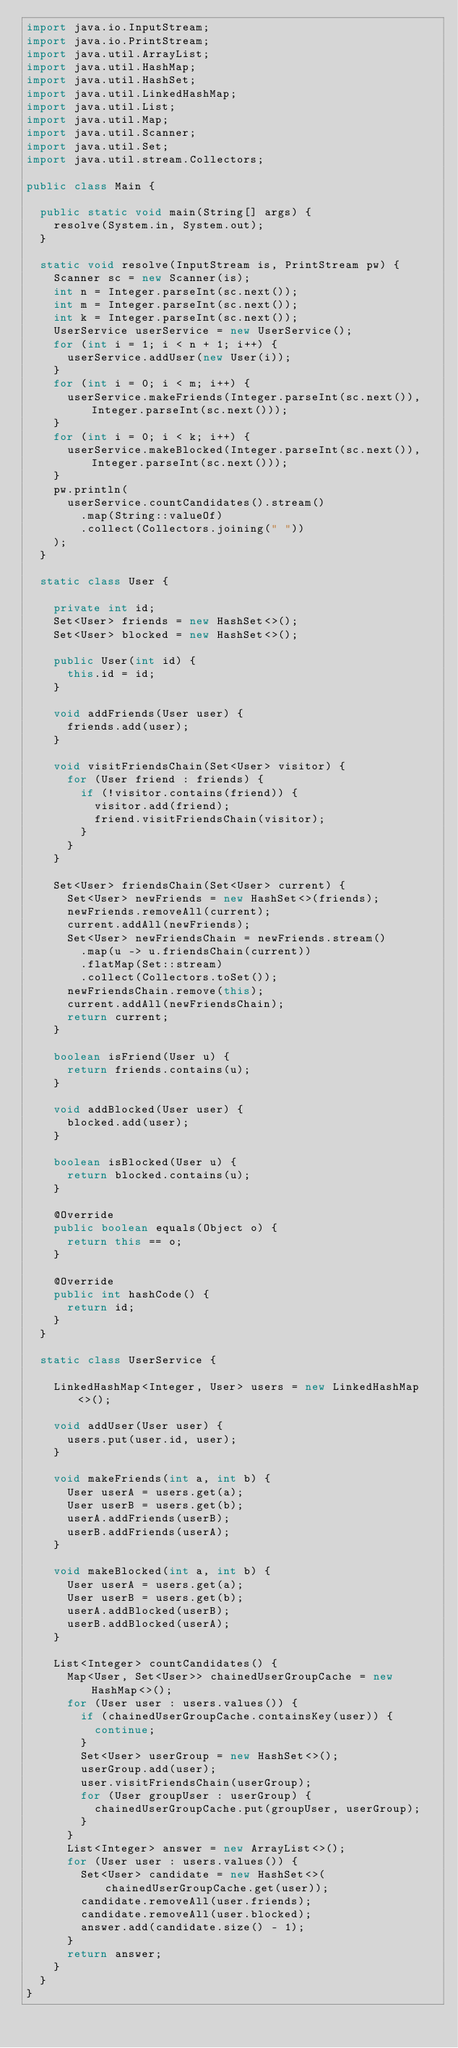<code> <loc_0><loc_0><loc_500><loc_500><_Java_>import java.io.InputStream;
import java.io.PrintStream;
import java.util.ArrayList;
import java.util.HashMap;
import java.util.HashSet;
import java.util.LinkedHashMap;
import java.util.List;
import java.util.Map;
import java.util.Scanner;
import java.util.Set;
import java.util.stream.Collectors;

public class Main {

  public static void main(String[] args) {
    resolve(System.in, System.out);
  }

  static void resolve(InputStream is, PrintStream pw) {
    Scanner sc = new Scanner(is);
    int n = Integer.parseInt(sc.next());
    int m = Integer.parseInt(sc.next());
    int k = Integer.parseInt(sc.next());
    UserService userService = new UserService();
    for (int i = 1; i < n + 1; i++) {
      userService.addUser(new User(i));
    }
    for (int i = 0; i < m; i++) {
      userService.makeFriends(Integer.parseInt(sc.next()), Integer.parseInt(sc.next()));
    }
    for (int i = 0; i < k; i++) {
      userService.makeBlocked(Integer.parseInt(sc.next()), Integer.parseInt(sc.next()));
    }
    pw.println(
      userService.countCandidates().stream()
        .map(String::valueOf)
        .collect(Collectors.joining(" "))
    );
  }

  static class User {

    private int id;
    Set<User> friends = new HashSet<>();
    Set<User> blocked = new HashSet<>();

    public User(int id) {
      this.id = id;
    }

    void addFriends(User user) {
      friends.add(user);
    }

    void visitFriendsChain(Set<User> visitor) {
      for (User friend : friends) {
        if (!visitor.contains(friend)) {
          visitor.add(friend);
          friend.visitFriendsChain(visitor);
        }
      }
    }

    Set<User> friendsChain(Set<User> current) {
      Set<User> newFriends = new HashSet<>(friends);
      newFriends.removeAll(current);
      current.addAll(newFriends);
      Set<User> newFriendsChain = newFriends.stream()
        .map(u -> u.friendsChain(current))
        .flatMap(Set::stream)
        .collect(Collectors.toSet());
      newFriendsChain.remove(this);
      current.addAll(newFriendsChain);
      return current;
    }

    boolean isFriend(User u) {
      return friends.contains(u);
    }

    void addBlocked(User user) {
      blocked.add(user);
    }

    boolean isBlocked(User u) {
      return blocked.contains(u);
    }

    @Override
    public boolean equals(Object o) {
      return this == o;
    }

    @Override
    public int hashCode() {
      return id;
    }
  }

  static class UserService {

    LinkedHashMap<Integer, User> users = new LinkedHashMap<>();

    void addUser(User user) {
      users.put(user.id, user);
    }

    void makeFriends(int a, int b) {
      User userA = users.get(a);
      User userB = users.get(b);
      userA.addFriends(userB);
      userB.addFriends(userA);
    }

    void makeBlocked(int a, int b) {
      User userA = users.get(a);
      User userB = users.get(b);
      userA.addBlocked(userB);
      userB.addBlocked(userA);
    }

    List<Integer> countCandidates() {
      Map<User, Set<User>> chainedUserGroupCache = new HashMap<>();
      for (User user : users.values()) {
        if (chainedUserGroupCache.containsKey(user)) {
          continue;
        }
        Set<User> userGroup = new HashSet<>();
        userGroup.add(user);
        user.visitFriendsChain(userGroup);
        for (User groupUser : userGroup) {
          chainedUserGroupCache.put(groupUser, userGroup);
        }
      }
      List<Integer> answer = new ArrayList<>();
      for (User user : users.values()) {
        Set<User> candidate = new HashSet<>(chainedUserGroupCache.get(user));
        candidate.removeAll(user.friends);
        candidate.removeAll(user.blocked);
        answer.add(candidate.size() - 1);
      }
      return answer;
    }
  }
}
</code> 